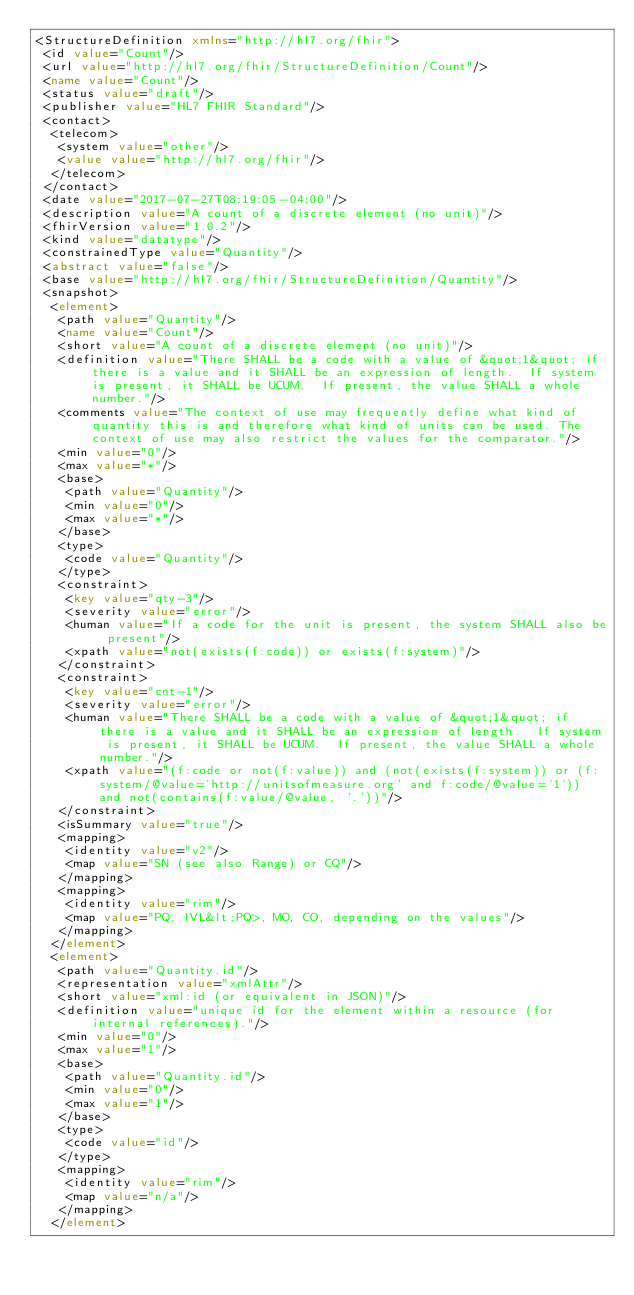Convert code to text. <code><loc_0><loc_0><loc_500><loc_500><_XML_><StructureDefinition xmlns="http://hl7.org/fhir">
 <id value="Count"/>
 <url value="http://hl7.org/fhir/StructureDefinition/Count"/>
 <name value="Count"/>
 <status value="draft"/>
 <publisher value="HL7 FHIR Standard"/>
 <contact>
  <telecom>
   <system value="other"/>
   <value value="http://hl7.org/fhir"/>
  </telecom>
 </contact>
 <date value="2017-07-27T08:19:05-04:00"/>
 <description value="A count of a discrete element (no unit)"/>
 <fhirVersion value="1.0.2"/>
 <kind value="datatype"/>
 <constrainedType value="Quantity"/>
 <abstract value="false"/>
 <base value="http://hl7.org/fhir/StructureDefinition/Quantity"/>
 <snapshot>
  <element>
   <path value="Quantity"/>
   <name value="Count"/>
   <short value="A count of a discrete element (no unit)"/>
   <definition value="There SHALL be a code with a value of &quot;1&quot; if there is a value and it SHALL be an expression of length.  If system is present, it SHALL be UCUM.  If present, the value SHALL a whole number."/>
   <comments value="The context of use may frequently define what kind of quantity this is and therefore what kind of units can be used. The context of use may also restrict the values for the comparator."/>
   <min value="0"/>
   <max value="*"/>
   <base>
    <path value="Quantity"/>
    <min value="0"/>
    <max value="*"/>
   </base>
   <type>
    <code value="Quantity"/>
   </type>
   <constraint>
    <key value="qty-3"/>
    <severity value="error"/>
    <human value="If a code for the unit is present, the system SHALL also be present"/>
    <xpath value="not(exists(f:code)) or exists(f:system)"/>
   </constraint>
   <constraint>
    <key value="cnt-1"/>
    <severity value="error"/>
    <human value="There SHALL be a code with a value of &quot;1&quot; if there is a value and it SHALL be an expression of length.  If system is present, it SHALL be UCUM.  If present, the value SHALL a whole number."/>
    <xpath value="(f:code or not(f:value)) and (not(exists(f:system)) or (f:system/@value='http://unitsofmeasure.org' and f:code/@value='1')) and not(contains(f:value/@value, '.'))"/>
   </constraint>
   <isSummary value="true"/>
   <mapping>
    <identity value="v2"/>
    <map value="SN (see also Range) or CQ"/>
   </mapping>
   <mapping>
    <identity value="rim"/>
    <map value="PQ, IVL&lt;PQ>, MO, CO, depending on the values"/>
   </mapping>
  </element>
  <element>
   <path value="Quantity.id"/>
   <representation value="xmlAttr"/>
   <short value="xml:id (or equivalent in JSON)"/>
   <definition value="unique id for the element within a resource (for internal references)."/>
   <min value="0"/>
   <max value="1"/>
   <base>
    <path value="Quantity.id"/>
    <min value="0"/>
    <max value="1"/>
   </base>
   <type>
    <code value="id"/>
   </type>
   <mapping>
    <identity value="rim"/>
    <map value="n/a"/>
   </mapping>
  </element></code> 